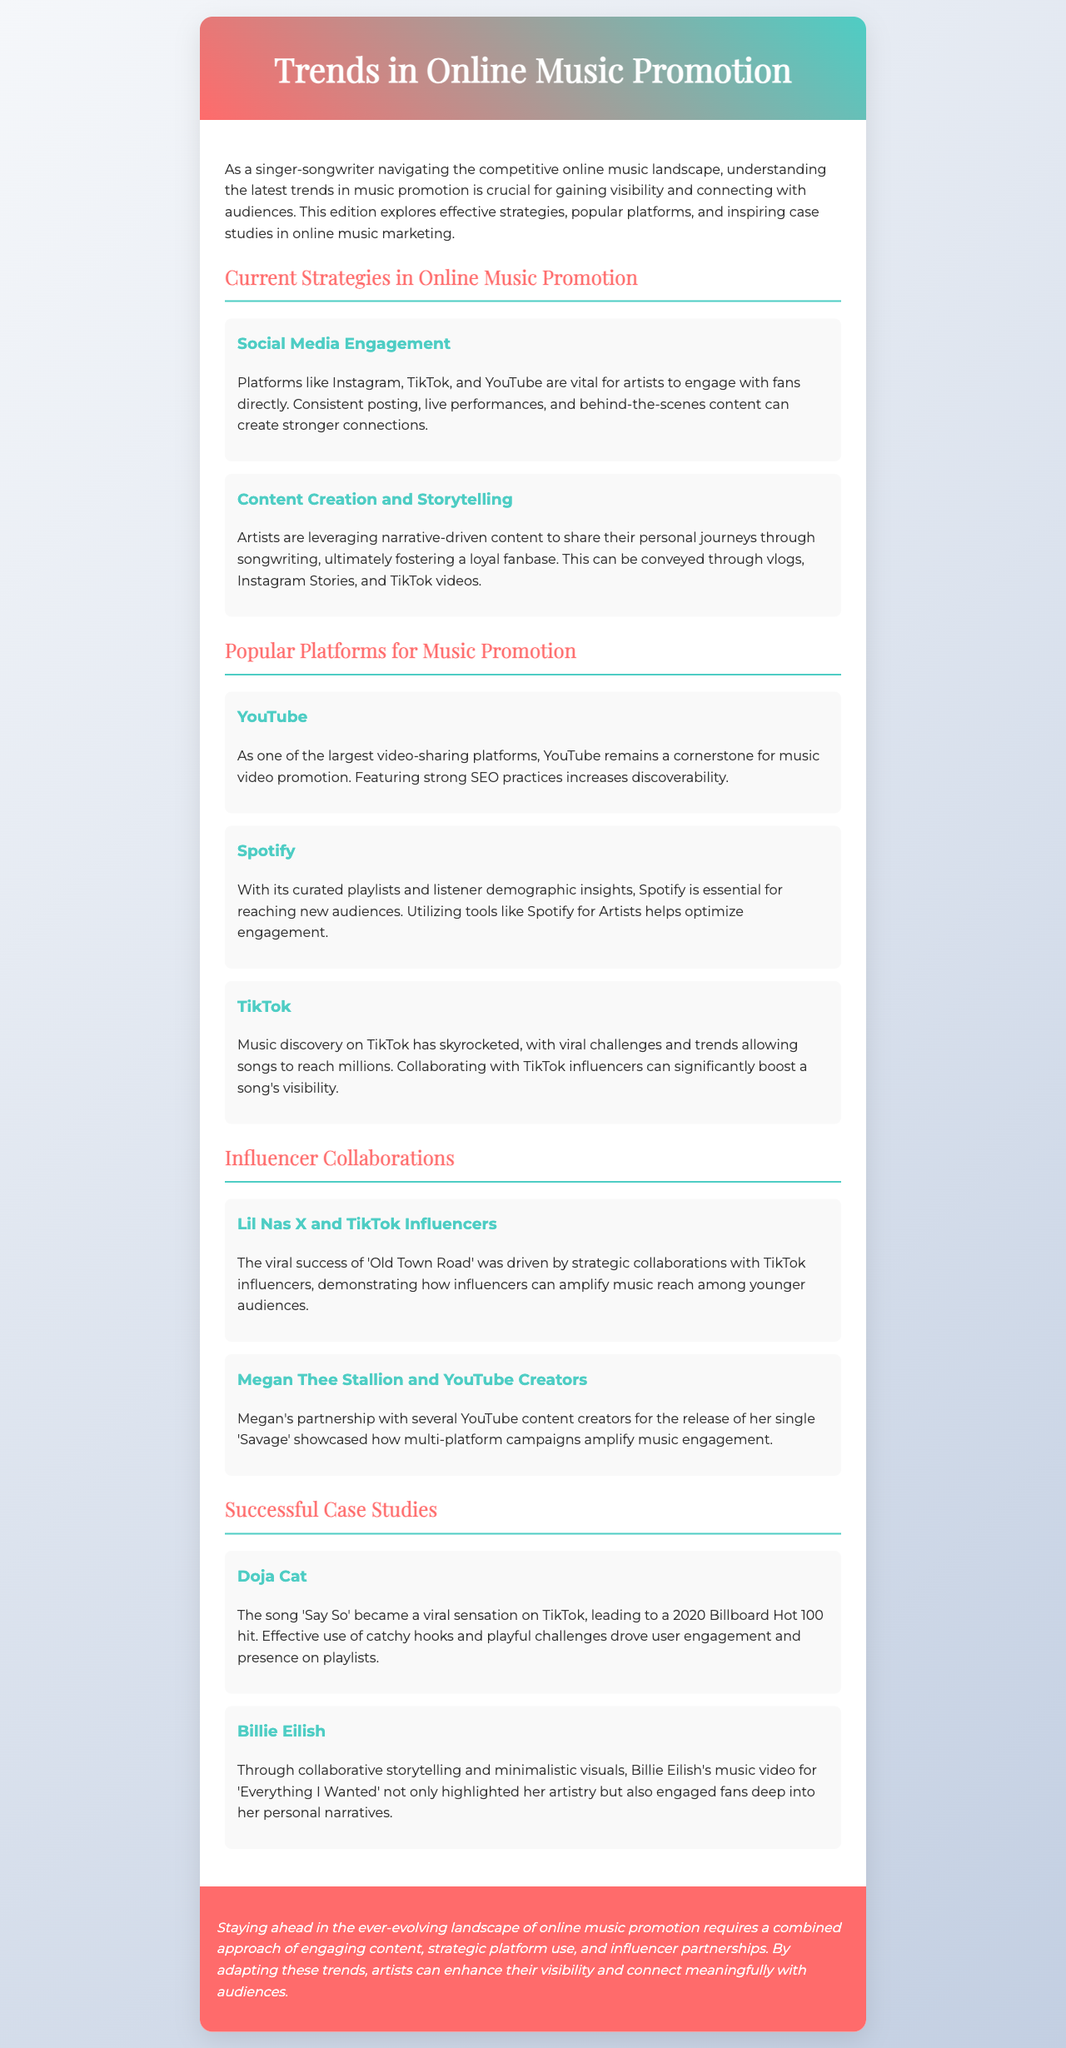What is a vital platform for artists to engage with fans? The document highlights social media platforms like Instagram, TikTok, and YouTube as vital for artist engagement with fans.
Answer: Instagram, TikTok, YouTube What is a key feature of YouTube for music promotion? The document states that featuring strong SEO practices increases discoverability on YouTube, making it key for music promotion.
Answer: SEO practices Who collaborated with TikTok influencers for their song? The document refers to Lil Nas X's strategic collaborations with TikTok influencers to drive the success of 'Old Town Road'.
Answer: Lil Nas X What narrative approach do artists leverage to create a loyal fanbase? The newsletter discusses how artists use narrative-driven content to share their personal journeys through songwriting.
Answer: Narrative-driven content Which song by Doja Cat became a viral sensation on TikTok? The document mentions the song 'Say So' as having become a viral sensation on TikTok, leading to a Billboard Hot 100 hit.
Answer: Say So How many case studies are discussed in the newsletter? The document outlines two successful case studies: Doja Cat and Billie Eilish, indicating that there are two case studies presented.
Answer: Two What is the primary purpose of this newsletter? The newsletter aims to explore effective strategies, popular platforms, and inspiring case studies in online music marketing for artists.
Answer: Explore effective strategies Which platform reported significant music discovery through viral challenges? The newsletter points out TikTok as a platform where music discovery has skyrocketed due to viral challenges.
Answer: TikTok 